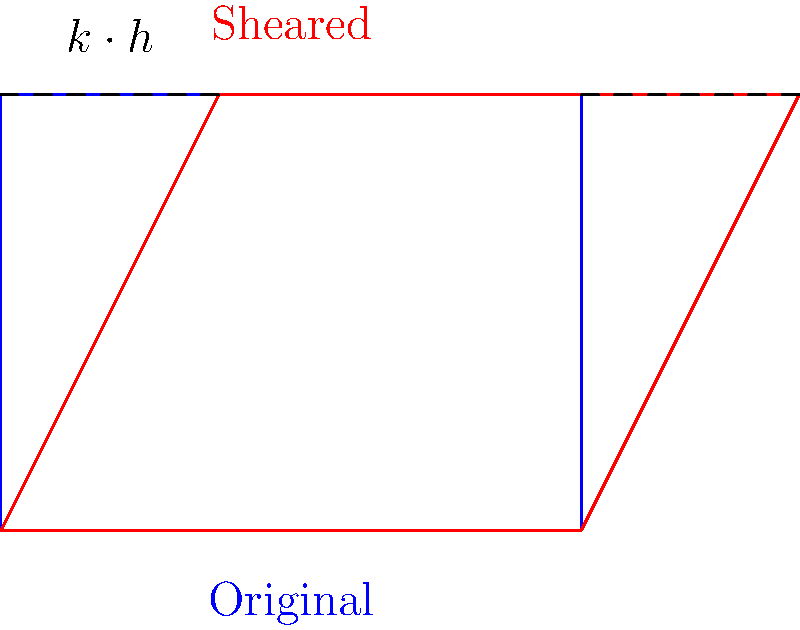A rectangular product photo needs to be sheared to create a skewed perspective for a new marketing campaign. The original photo is 4 units wide and 3 units tall. If the shear factor $k$ is 0.5 and applied horizontally at the top edge, what is the new width of the photo after shearing? To solve this problem, we need to follow these steps:

1. Understand the shear transformation:
   - Shearing preserves the base of the rectangle and shifts the top edge horizontally.
   - The amount of shift is proportional to the height and the shear factor.

2. Identify the given information:
   - Original width: 4 units
   - Original height: 3 units
   - Shear factor (k): 0.5

3. Calculate the horizontal shift of the top edge:
   - Shift = $k \cdot h$, where $h$ is the height
   - Shift = $0.5 \cdot 3 = 1.5$ units

4. Determine the new width:
   - New width = Original width + Shift
   - New width = $4 + 1.5 = 5.5$ units

Therefore, after shearing, the new width of the product photo is 5.5 units.
Answer: 5.5 units 